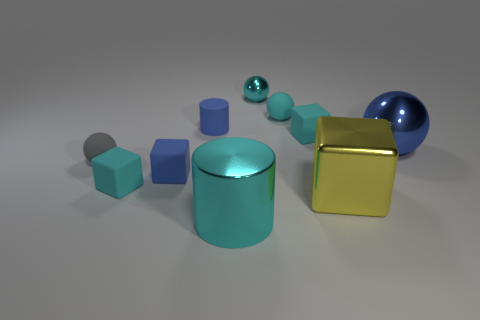Subtract all big blue balls. How many balls are left? 3 Subtract all blue balls. How many cyan cubes are left? 2 Subtract 1 blocks. How many blocks are left? 3 Subtract all gray balls. How many balls are left? 3 Subtract all gray spheres. Subtract all purple blocks. How many spheres are left? 3 Subtract all spheres. How many objects are left? 6 Subtract 1 blue blocks. How many objects are left? 9 Subtract all small metal objects. Subtract all large green blocks. How many objects are left? 9 Add 1 cyan matte balls. How many cyan matte balls are left? 2 Add 3 rubber balls. How many rubber balls exist? 5 